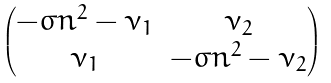Convert formula to latex. <formula><loc_0><loc_0><loc_500><loc_500>\begin{pmatrix} - \sigma n ^ { 2 } - \nu _ { 1 } & \nu _ { 2 } \\ \nu _ { 1 } & - \sigma n ^ { 2 } - \nu _ { 2 } \\ \end{pmatrix}</formula> 